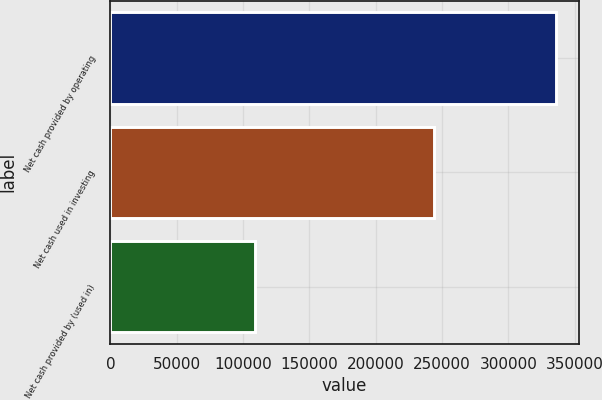Convert chart to OTSL. <chart><loc_0><loc_0><loc_500><loc_500><bar_chart><fcel>Net cash provided by operating<fcel>Net cash used in investing<fcel>Net cash provided by (used in)<nl><fcel>336032<fcel>243689<fcel>108787<nl></chart> 